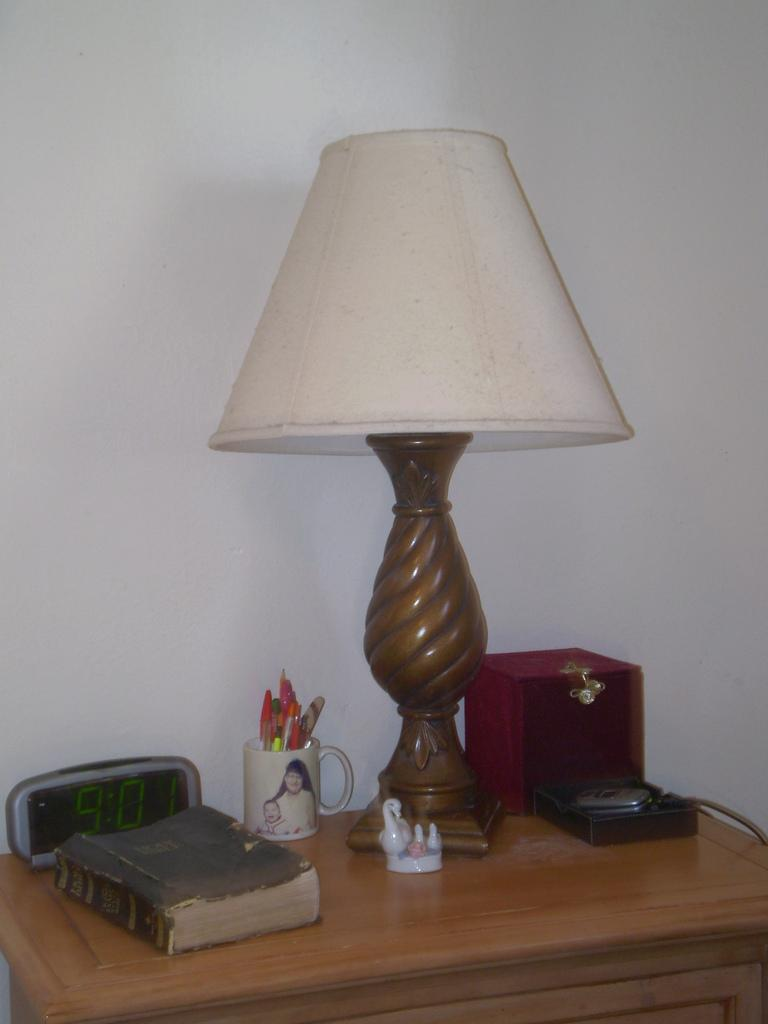What piece of furniture is visible in the image? There is a table in the image. What items can be seen on the table? A book, a clock, pencils in a cup, a toy, a lamp, and a box are on the table. What might be used for writing or drawing on the table? Pencils in a cup are on the table. What object might be used for measuring time on the table? A clock is on the table. What type of alarm can be heard going off in the image? There is no alarm present or audible in the image. What type of thrill can be seen in the image? There is no thrill or excitement depicted in the image; it shows a table with various objects on it. 